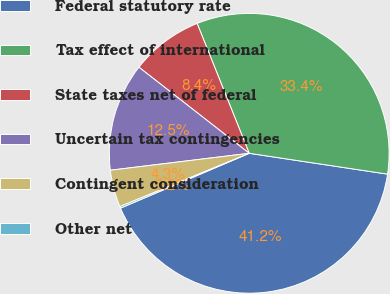<chart> <loc_0><loc_0><loc_500><loc_500><pie_chart><fcel>Federal statutory rate<fcel>Tax effect of international<fcel>State taxes net of federal<fcel>Uncertain tax contingencies<fcel>Contingent consideration<fcel>Other net<nl><fcel>41.21%<fcel>33.45%<fcel>8.38%<fcel>12.48%<fcel>4.29%<fcel>0.19%<nl></chart> 